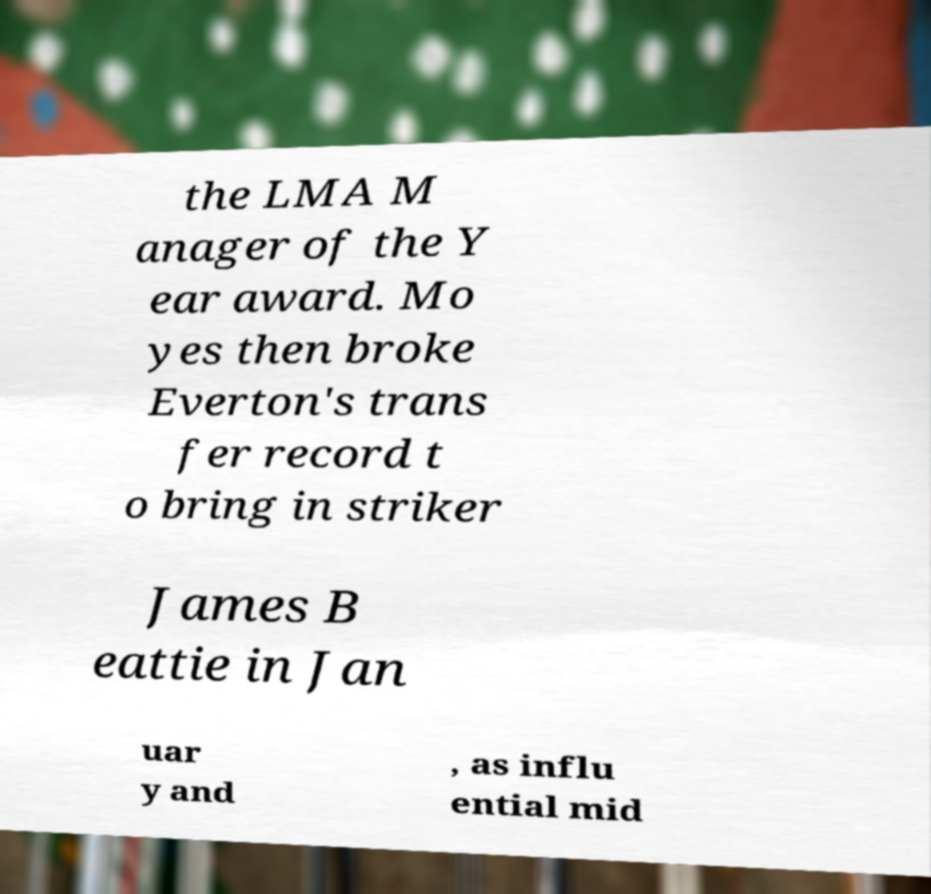There's text embedded in this image that I need extracted. Can you transcribe it verbatim? the LMA M anager of the Y ear award. Mo yes then broke Everton's trans fer record t o bring in striker James B eattie in Jan uar y and , as influ ential mid 